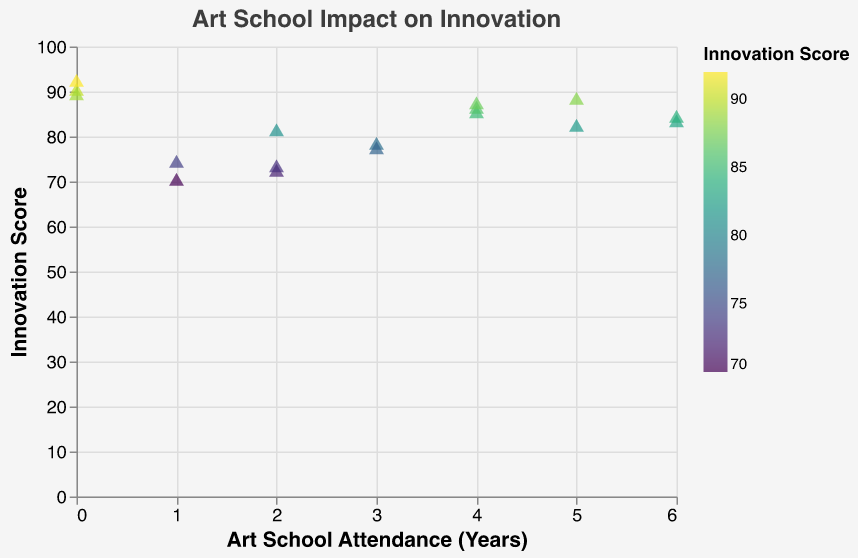What's the title of the plot? The title is mentioned at the top of the plot.
Answer: Art School Impact on Innovation How many data points are shown in the plot? Count the number of individual points shown in the scatter plot.
Answer: 17 What is the highest Innovation Score achieved by an artist? Identify the data point with the highest value on the y-axis (Innovation Score).
Answer: 92 Which artist has the longest art school attendance? Check the x-axis for the highest value and refer to the tooltip to identify the artist.
Answer: Jack Martinez Compare the Innovation Scores between artists with 0 years and 6 years of Art School Attendance. Identify the data points for attendance of 0 and 6 years and compare their Innovation Scores. 0 years: Emily Clarkson (90), Charlotte King (92), Evelyn Price (89); 6 years: Jack Martinez (83), Ella Adams (84)
Answer: Artists with 0 years have higher Innovation Scores How does Art School Attendance correlate with Innovation Score? Observe any general trend or pattern in the scatter plot to determine the correlation between the x-axis and y-axis values.
Answer: No clear correlation Out of artists who attended art school for 2 years, who has the highest Innovation Score? Identify the points with 2 years of attendance and compare the Innovation Scores.
Answer: Grace Allen Is there a noticeable difference in Innovation Scores based on whether artists attended art school versus those who didn't? Compare the range and average Innovation Scores of artists with 0 years attendance versus those with any attendance.
Answer: Artists with 0 years tend to have high Innovation Scores, similar to those who attended art school Which colors in the plot represent higher Innovation Scores? Look at the color scale and legend to identify which colors correspond to higher Innovation Scores.
Answer: Darker shades 